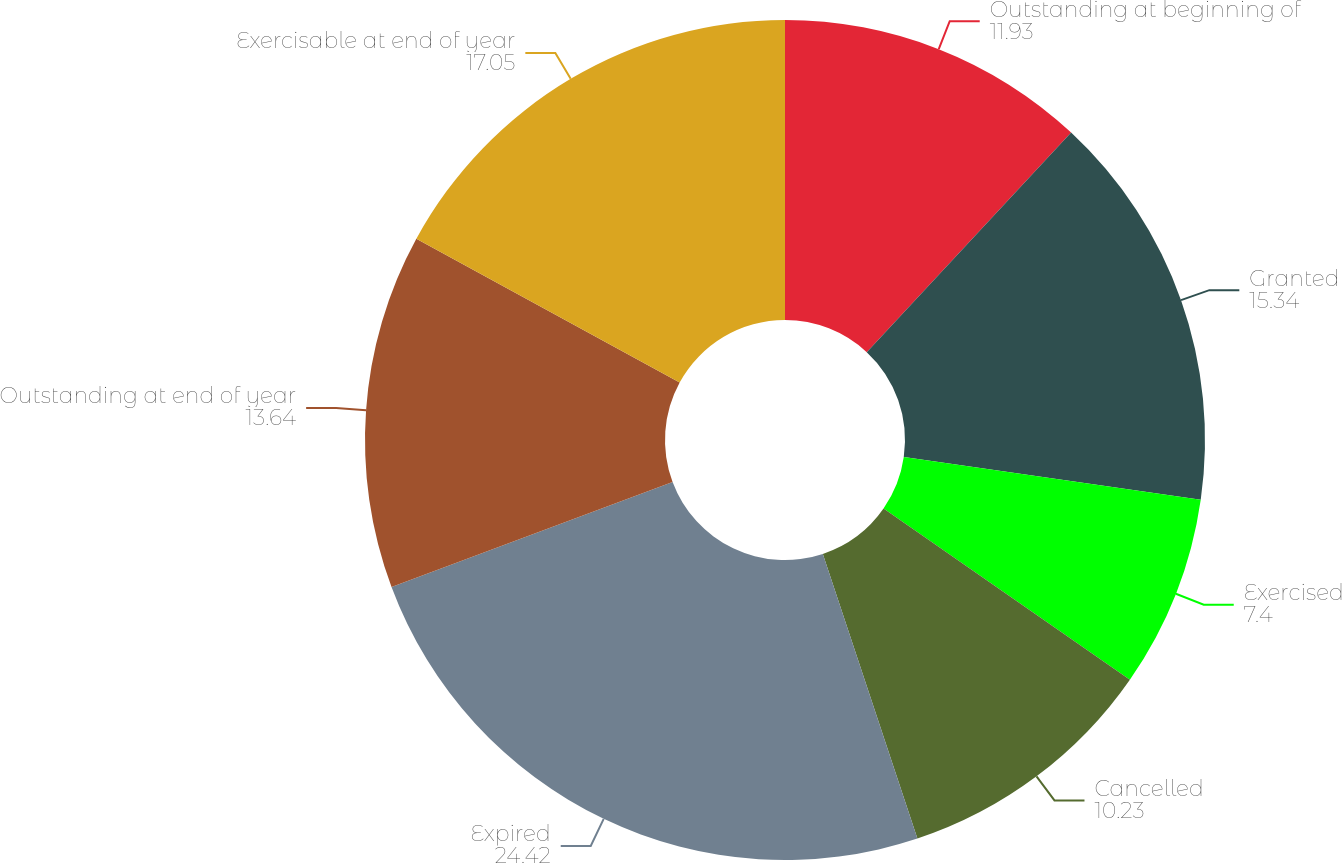Convert chart. <chart><loc_0><loc_0><loc_500><loc_500><pie_chart><fcel>Outstanding at beginning of<fcel>Granted<fcel>Exercised<fcel>Cancelled<fcel>Expired<fcel>Outstanding at end of year<fcel>Exercisable at end of year<nl><fcel>11.93%<fcel>15.34%<fcel>7.4%<fcel>10.23%<fcel>24.42%<fcel>13.64%<fcel>17.05%<nl></chart> 